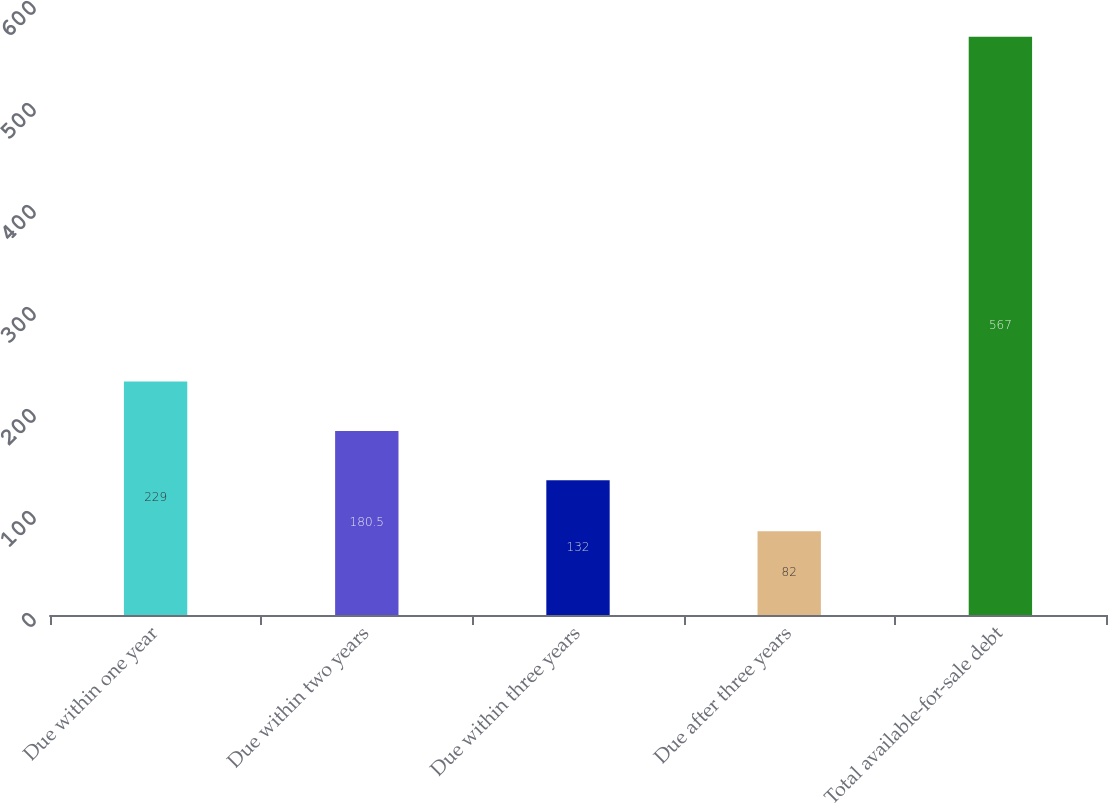<chart> <loc_0><loc_0><loc_500><loc_500><bar_chart><fcel>Due within one year<fcel>Due within two years<fcel>Due within three years<fcel>Due after three years<fcel>Total available-for-sale debt<nl><fcel>229<fcel>180.5<fcel>132<fcel>82<fcel>567<nl></chart> 